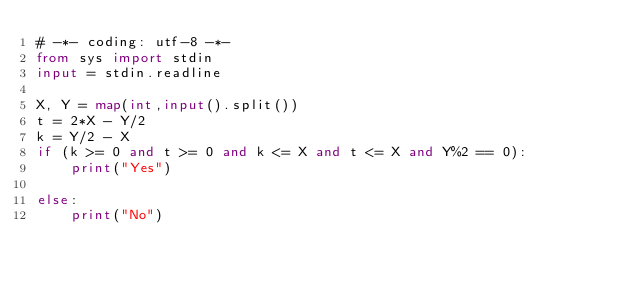<code> <loc_0><loc_0><loc_500><loc_500><_Python_># -*- coding: utf-8 -*-
from sys import stdin
input = stdin.readline

X, Y = map(int,input().split())
t = 2*X - Y/2
k = Y/2 - X
if (k >= 0 and t >= 0 and k <= X and t <= X and Y%2 == 0):
    print("Yes")

else:
    print("No")</code> 